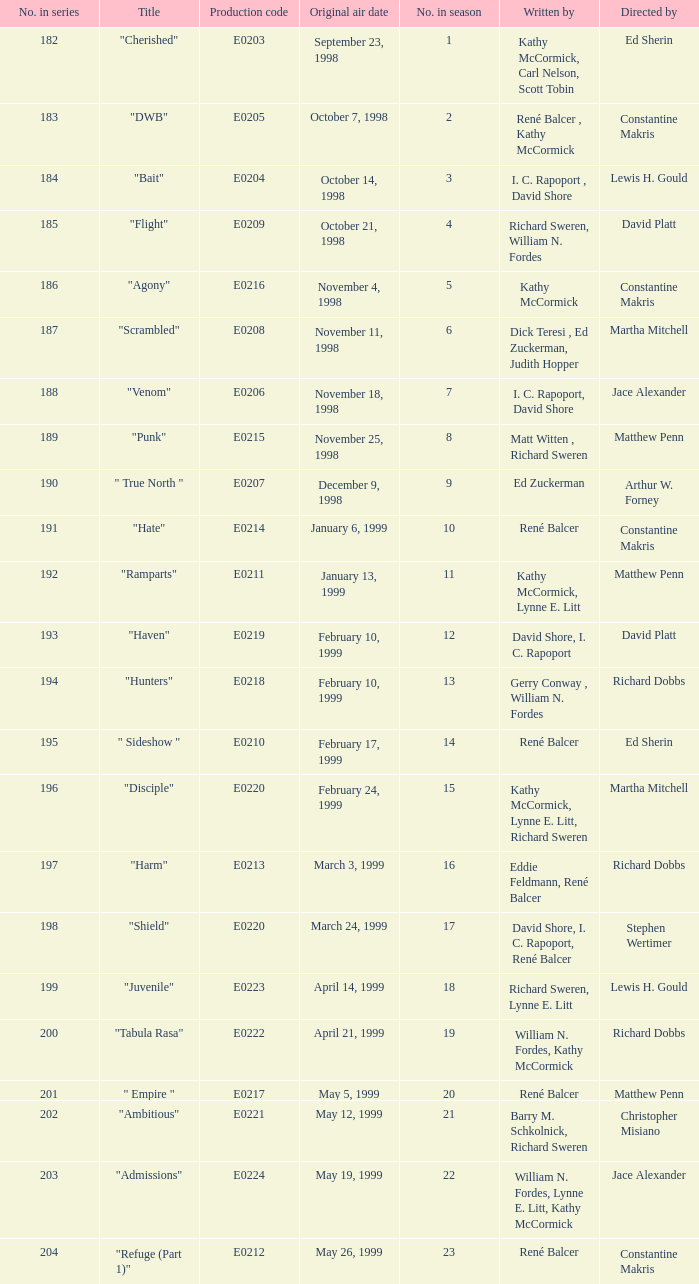What is the title of the episode with the original air date October 21, 1998? "Flight". 